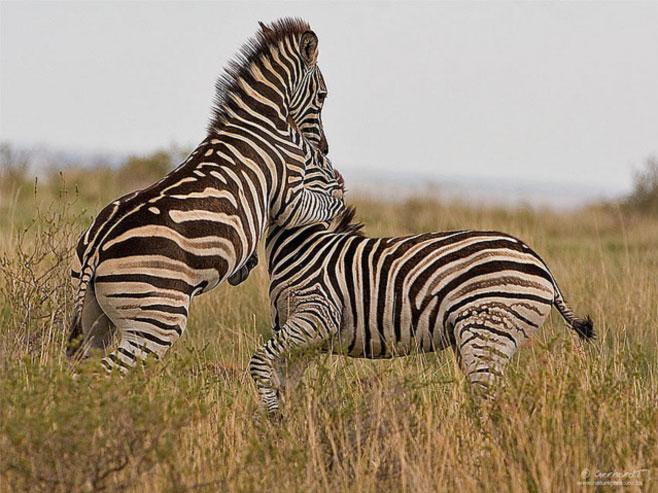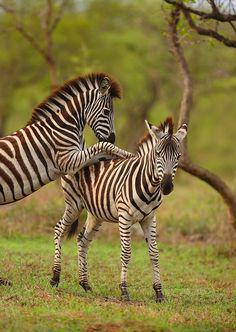The first image is the image on the left, the second image is the image on the right. Given the left and right images, does the statement "The left and right image contains the same number of zebras with at least two looking at two face to face." hold true? Answer yes or no. Yes. The first image is the image on the left, the second image is the image on the right. Assess this claim about the two images: "Each image contains exactly two zebras, and the left image shows one zebra standing on its hind legs face-to-face and in contact with another zebra.". Correct or not? Answer yes or no. Yes. 